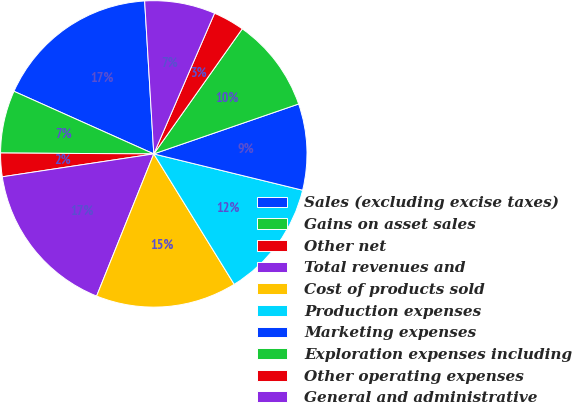<chart> <loc_0><loc_0><loc_500><loc_500><pie_chart><fcel>Sales (excluding excise taxes)<fcel>Gains on asset sales<fcel>Other net<fcel>Total revenues and<fcel>Cost of products sold<fcel>Production expenses<fcel>Marketing expenses<fcel>Exploration expenses including<fcel>Other operating expenses<fcel>General and administrative<nl><fcel>17.35%<fcel>6.61%<fcel>2.48%<fcel>16.53%<fcel>14.88%<fcel>12.4%<fcel>9.09%<fcel>9.92%<fcel>3.31%<fcel>7.44%<nl></chart> 